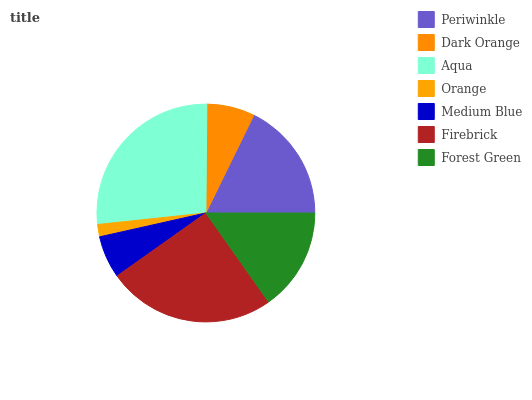Is Orange the minimum?
Answer yes or no. Yes. Is Aqua the maximum?
Answer yes or no. Yes. Is Dark Orange the minimum?
Answer yes or no. No. Is Dark Orange the maximum?
Answer yes or no. No. Is Periwinkle greater than Dark Orange?
Answer yes or no. Yes. Is Dark Orange less than Periwinkle?
Answer yes or no. Yes. Is Dark Orange greater than Periwinkle?
Answer yes or no. No. Is Periwinkle less than Dark Orange?
Answer yes or no. No. Is Forest Green the high median?
Answer yes or no. Yes. Is Forest Green the low median?
Answer yes or no. Yes. Is Aqua the high median?
Answer yes or no. No. Is Aqua the low median?
Answer yes or no. No. 